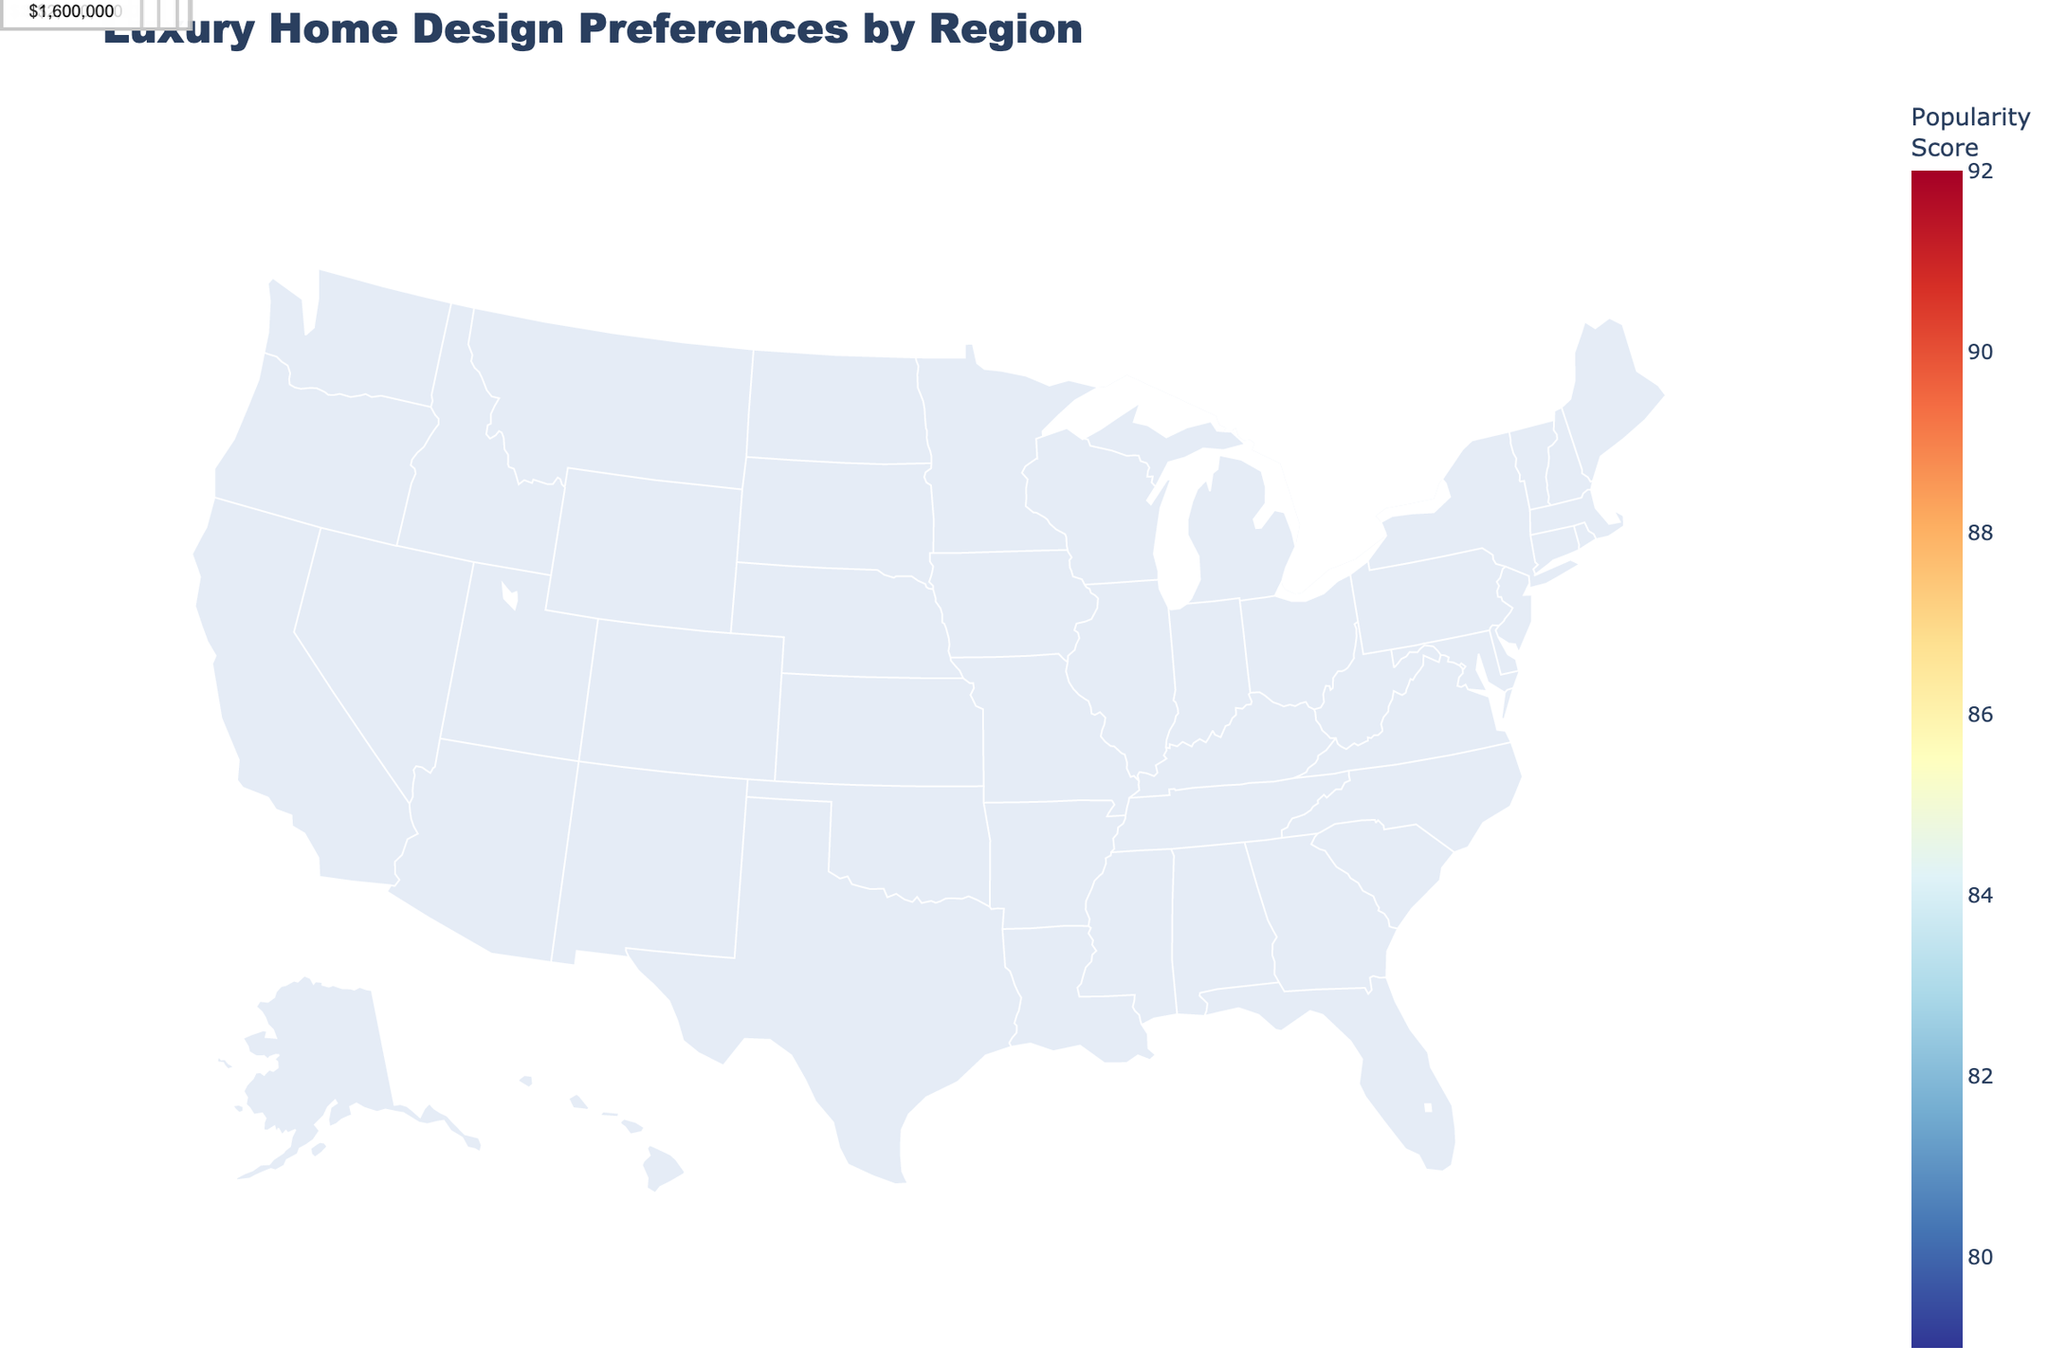What is the most popular luxury home design style in California? According to the figure, the regions are annotated with details of the design style and popularity score. For California, the label shows "Modern Mediterranean" with a popularity score of 92.
Answer: Modern Mediterranean Which region has the highest average budget for luxury home renovations? The figure provides average budget annotations for each region. California has the highest average budget at $2,500,000.
Answer: California How does the popularity score for the "Traditional Colonial" style in New England compare to the "Urban Loft" style in New York? By looking at the annotations, we see "Traditional Colonial" in New England has a popularity score of 85, while "Urban Loft" in New York has a score of 90.
Answer: New York is higher What is the average budget for luxury home renovations in Texas? The figure annotates the average budget for Texas as $1,500,000.
Answer: $1,500,000 Which region has the lowest popularity score for their design style? The annotations indicate that the Southwest region, with its "Adobe Revival" style, has the lowest popularity score of 79.
Answer: Southwest What are the design styles and their respective regions that have popularity scores over 85? The annotations show that regions with popularity scores over 85 are California, Florida, New York, and Hawaii. Their design styles are "Modern Mediterranean," "Coastal Contemporary," "Urban Loft," and "Tropical Bungalow," respectively.
Answer: California, Florida, New York, Hawaii Compute the range of average budgets across all regions. The highest average budget is $2,500,000 in California, and the lowest is $1,100,000 in the Midwest. The range is $2,500,000 - $1,100,000 = $1,400,000.
Answer: $1,400,000 Compare the popularity score and average budget between the Pacific Northwest and Colorado. The Pacific Northwest has a popularity score of 87 and an average budget of $1,700,000. Colorado has a popularity score of 84 and an average budget of $1,600,000.
Answer: Pacific Northwest is higher in both Which region emphasizes eco-friendly designs, and what is its average budget? The annotation for the Pacific Northwest mentions "Eco-Friendly Modern" with an average budget of $1,700,000.
Answer: Pacific Northwest, $1,700,000 What's the total average budget for New England, Texas, and Colorado combined? Summing the average budgets: New England ($1,200,000) + Texas ($1,500,000) + Colorado ($1,600,000) = $4,300,000.
Answer: $4,300,000 